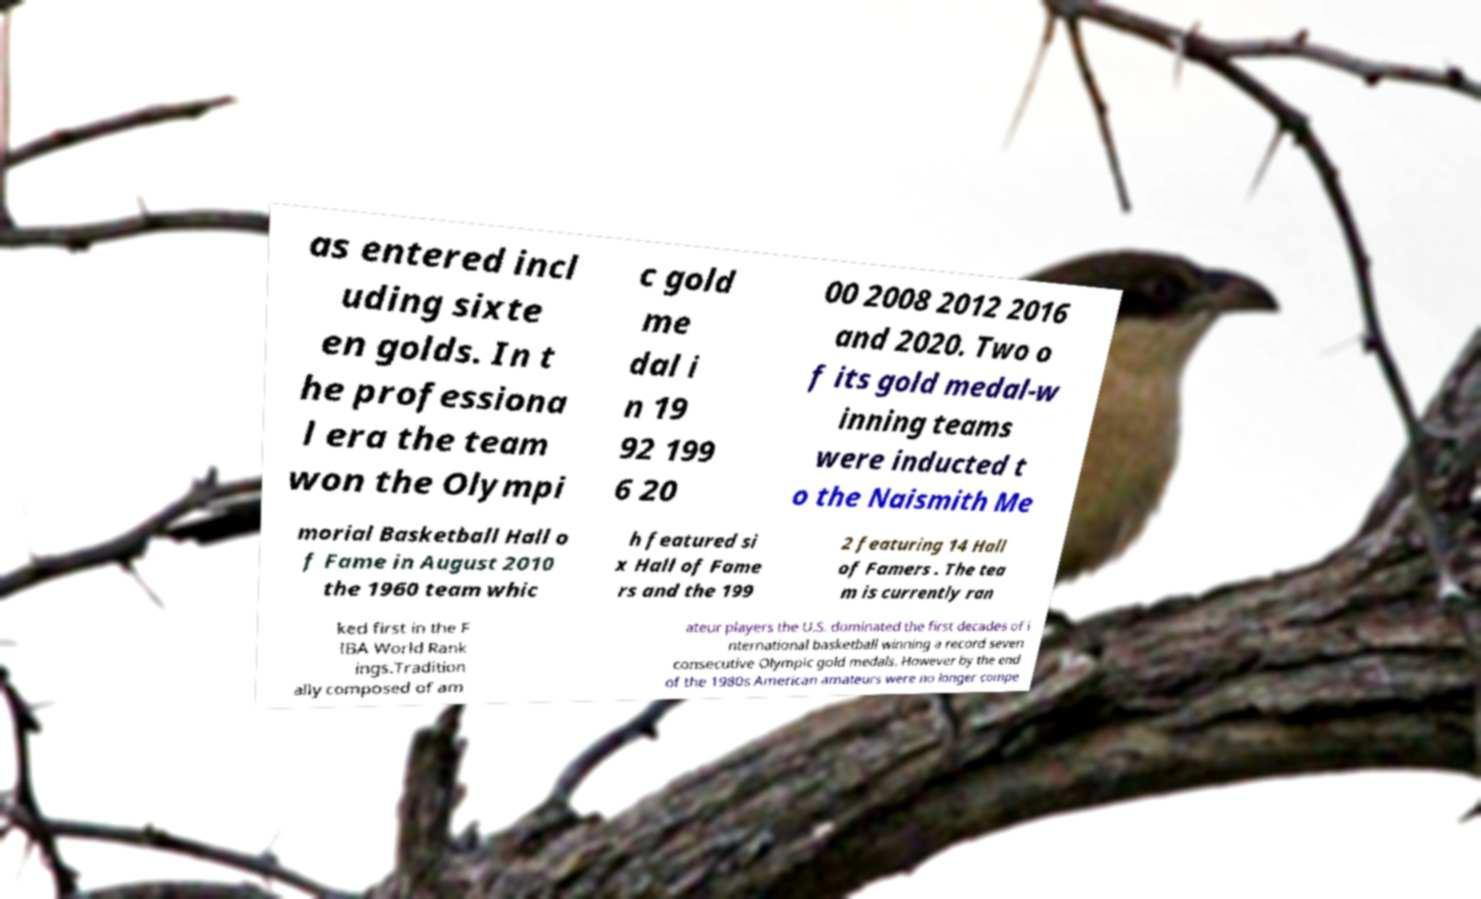Could you extract and type out the text from this image? as entered incl uding sixte en golds. In t he professiona l era the team won the Olympi c gold me dal i n 19 92 199 6 20 00 2008 2012 2016 and 2020. Two o f its gold medal-w inning teams were inducted t o the Naismith Me morial Basketball Hall o f Fame in August 2010 the 1960 team whic h featured si x Hall of Fame rs and the 199 2 featuring 14 Hall of Famers . The tea m is currently ran ked first in the F IBA World Rank ings.Tradition ally composed of am ateur players the U.S. dominated the first decades of i nternational basketball winning a record seven consecutive Olympic gold medals. However by the end of the 1980s American amateurs were no longer compe 